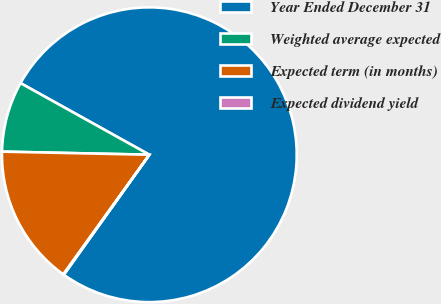Convert chart to OTSL. <chart><loc_0><loc_0><loc_500><loc_500><pie_chart><fcel>Year Ended December 31<fcel>Weighted average expected<fcel>Expected term (in months)<fcel>Expected dividend yield<nl><fcel>76.78%<fcel>7.74%<fcel>15.41%<fcel>0.07%<nl></chart> 